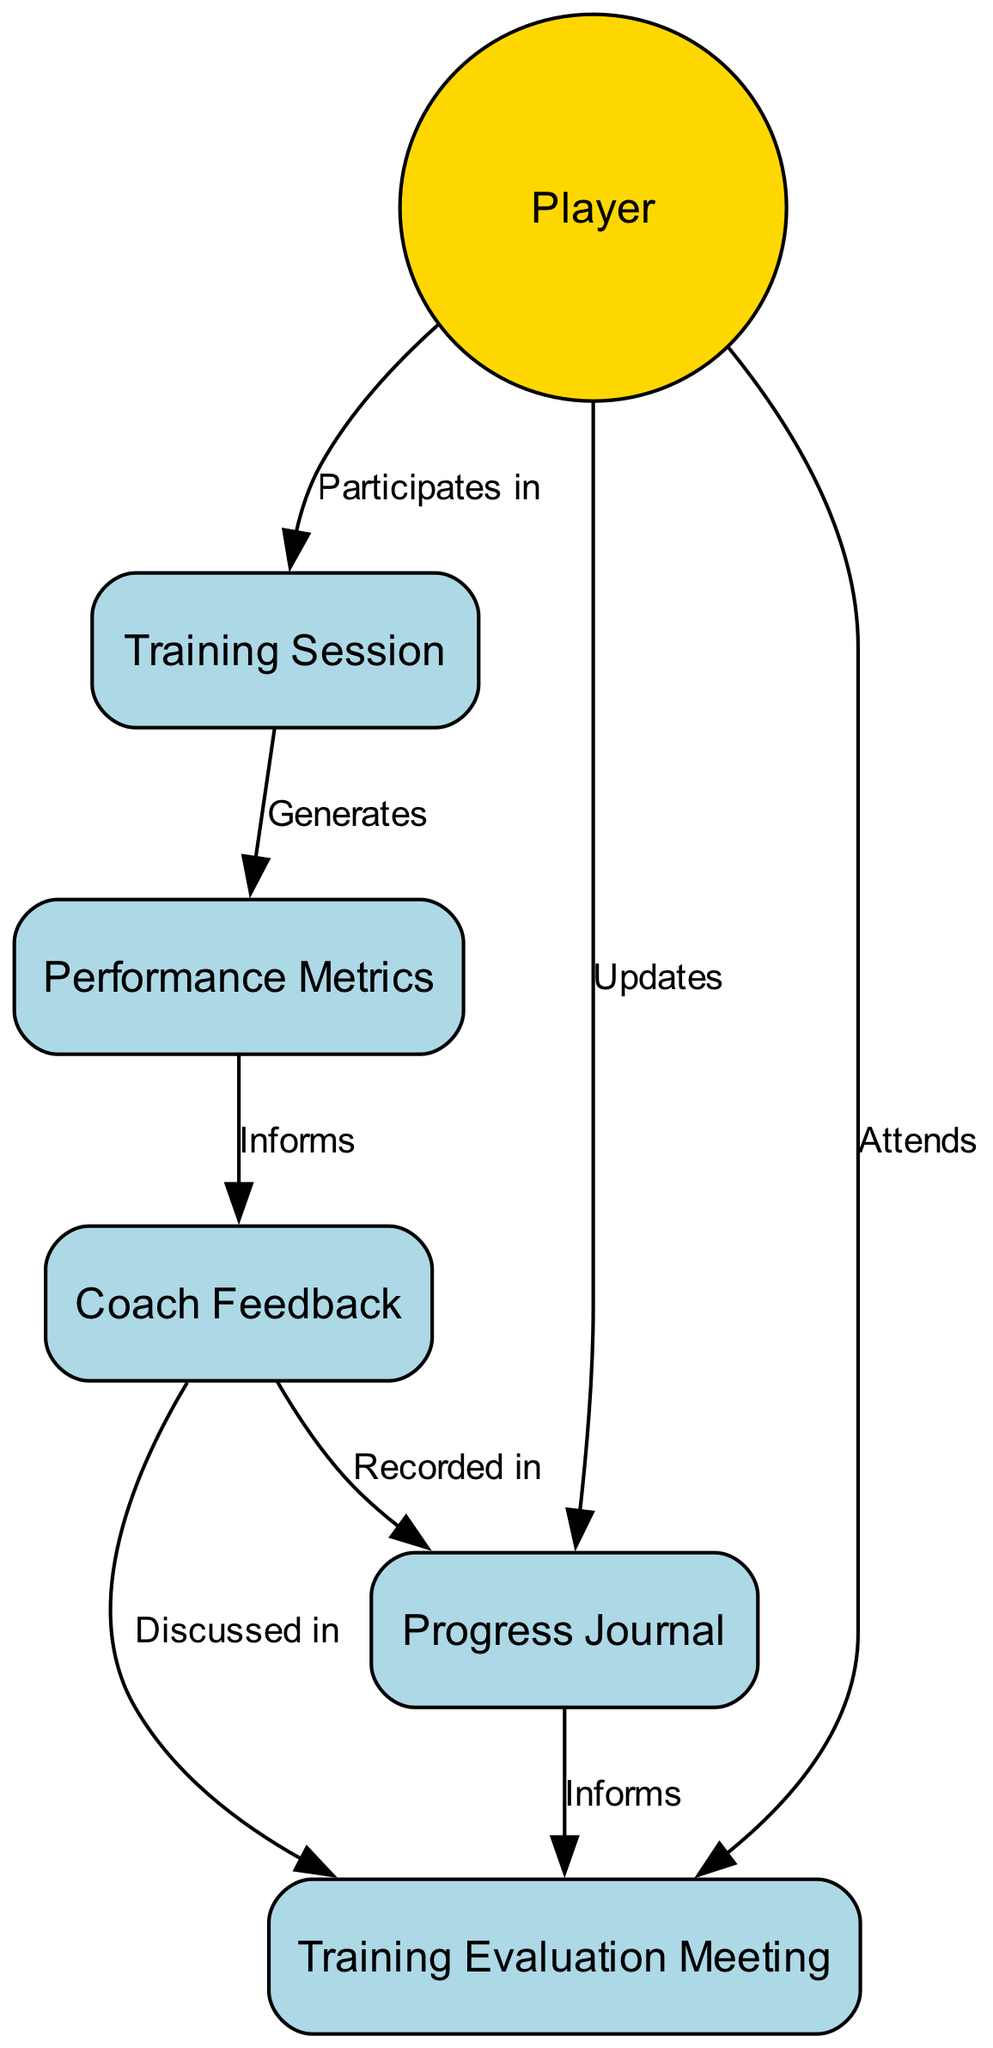What is the role of the Player in the diagram? The Player is depicted as the Actor who participates in the Training Session and updates the Progress Journal, highlighting their active involvement in tracking training activities.
Answer: Actor How many interactions are shown in the diagram? The diagram lists a total of eight distinct interactions between the various elements, indicating the flow of information and activities involved in training and feedback.
Answer: 8 What does the Training Session generate? The Training Session leads to the generation of Performance Metrics, reflecting the quantitative data derived from the training activities that evaluate the player’s performance.
Answer: Performance Metrics Which object records the Coach Feedback? Coach Feedback is recorded in the Progress Journal, illustrating the method of logging the coach's insights and evaluations after reviewing the performance metrics.
Answer: Progress Journal What is discussed in the Training Evaluation Meeting? The Training Evaluation Meeting serves as a platform where Coach Feedback is discussed alongside the player's training progress, emphasizing the collaborative nature of the evaluation process.
Answer: Coach Feedback Which two objects are updated by the Player? The Player updates both the Progress Journal and attends the Training Evaluation Meeting, showcasing their continued involvement in documenting training and engaging in progress discussions.
Answer: Progress Journal, Training Evaluation Meeting What informs the Coach Feedback? The Coach Feedback is informed by the Performance Metrics, indicating that the quantitative data collected during training is crucial for providing constructive feedback to the player.
Answer: Performance Metrics What is the purpose of the Training Evaluation Meeting? The purpose of the Training Evaluation Meeting is to facilitate discussions about the player’s progress and coach feedback, ensuring that both parties align on training strategies based on the performance evaluations.
Answer: Discuss progress How does the Performance Metrics relate to the Training Session? The Performance Metrics directly results from the Training Session, establishing a clear connection between the activities performed during training and the subsequent data collected to evaluate those activities.
Answer: Generates 